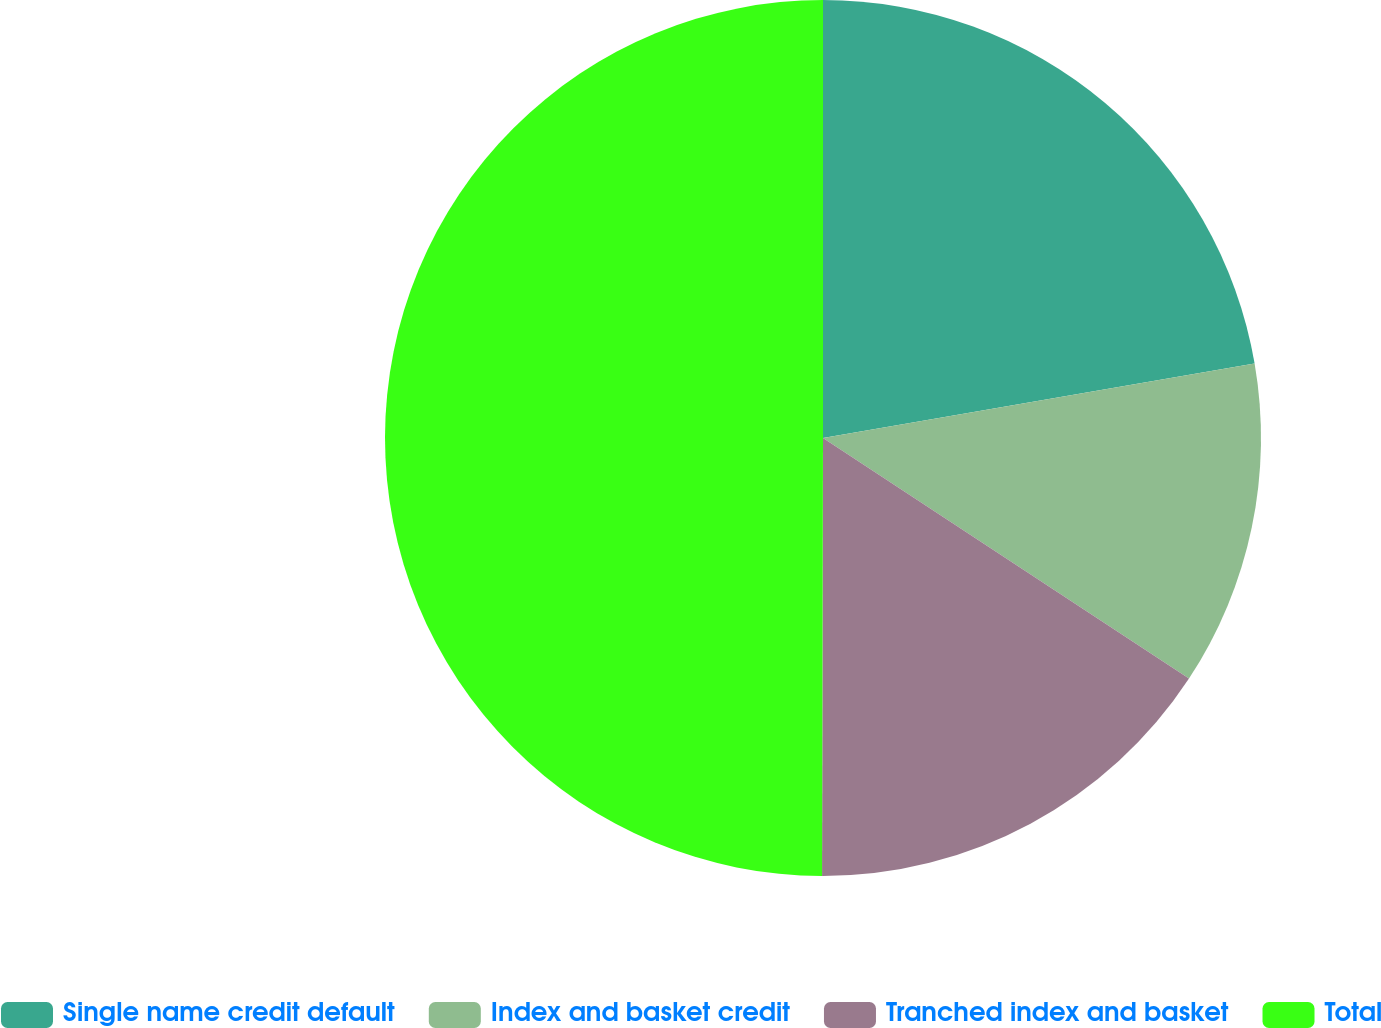<chart> <loc_0><loc_0><loc_500><loc_500><pie_chart><fcel>Single name credit default<fcel>Index and basket credit<fcel>Tranched index and basket<fcel>Total<nl><fcel>22.28%<fcel>11.98%<fcel>15.78%<fcel>49.97%<nl></chart> 